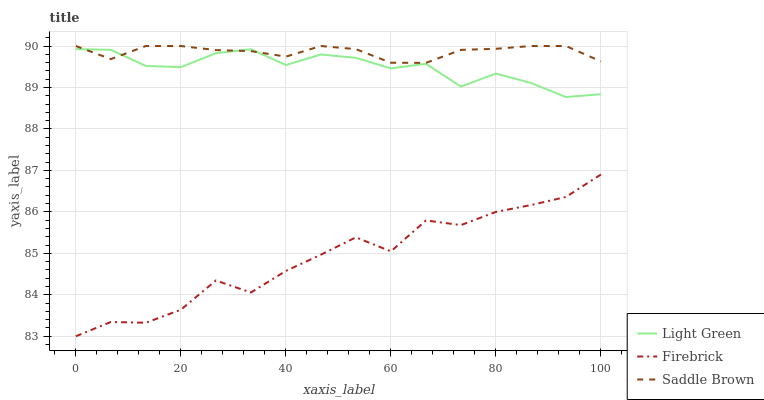Does Firebrick have the minimum area under the curve?
Answer yes or no. Yes. Does Saddle Brown have the maximum area under the curve?
Answer yes or no. Yes. Does Light Green have the minimum area under the curve?
Answer yes or no. No. Does Light Green have the maximum area under the curve?
Answer yes or no. No. Is Saddle Brown the smoothest?
Answer yes or no. Yes. Is Firebrick the roughest?
Answer yes or no. Yes. Is Light Green the smoothest?
Answer yes or no. No. Is Light Green the roughest?
Answer yes or no. No. Does Firebrick have the lowest value?
Answer yes or no. Yes. Does Light Green have the lowest value?
Answer yes or no. No. Does Saddle Brown have the highest value?
Answer yes or no. Yes. Does Light Green have the highest value?
Answer yes or no. No. Is Firebrick less than Saddle Brown?
Answer yes or no. Yes. Is Light Green greater than Firebrick?
Answer yes or no. Yes. Does Light Green intersect Saddle Brown?
Answer yes or no. Yes. Is Light Green less than Saddle Brown?
Answer yes or no. No. Is Light Green greater than Saddle Brown?
Answer yes or no. No. Does Firebrick intersect Saddle Brown?
Answer yes or no. No. 